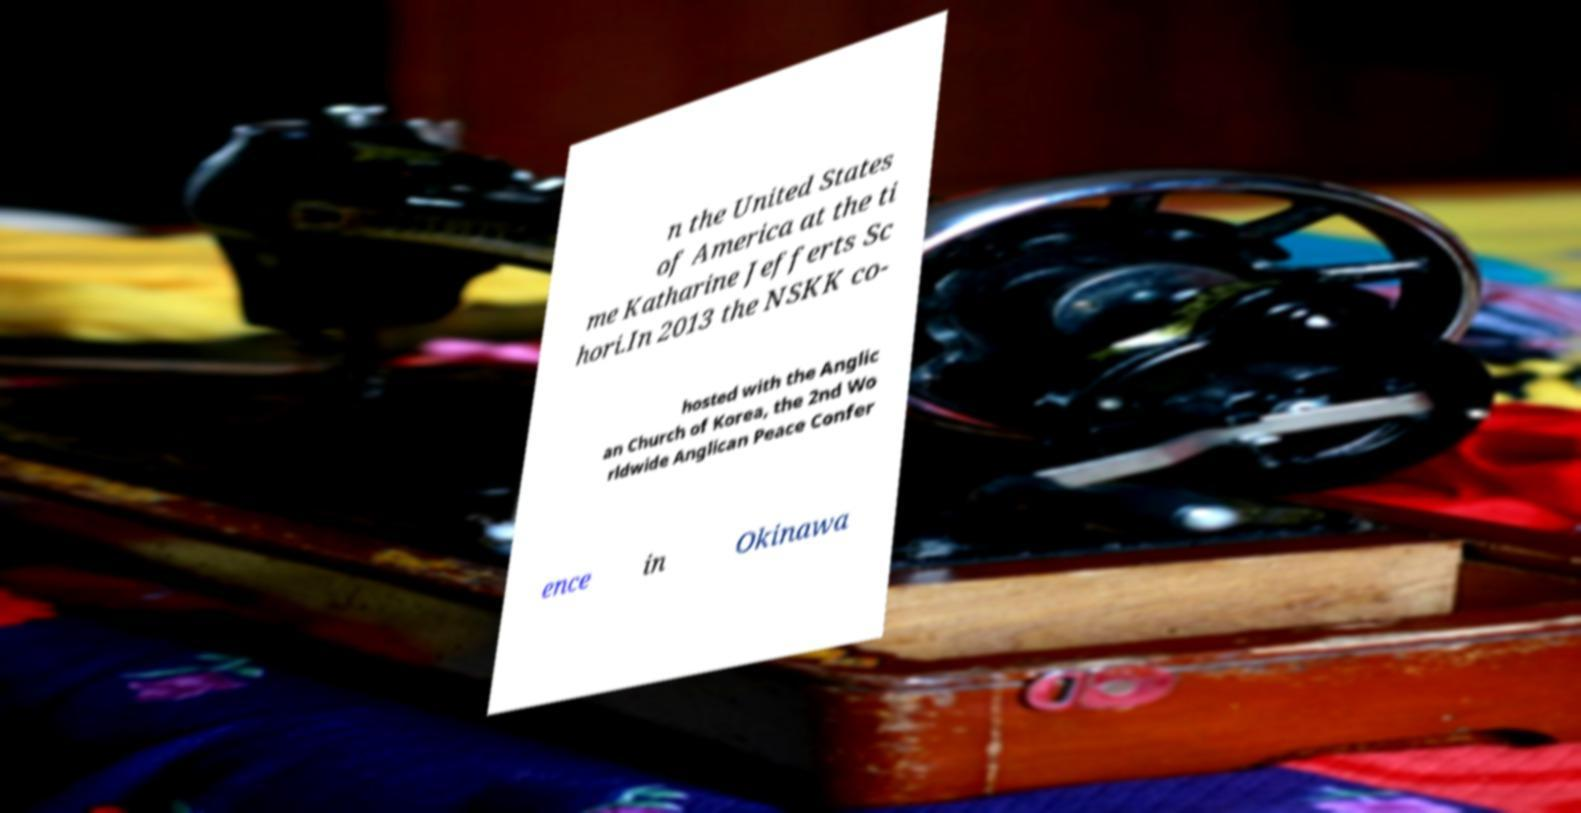Please read and relay the text visible in this image. What does it say? n the United States of America at the ti me Katharine Jefferts Sc hori.In 2013 the NSKK co- hosted with the Anglic an Church of Korea, the 2nd Wo rldwide Anglican Peace Confer ence in Okinawa 